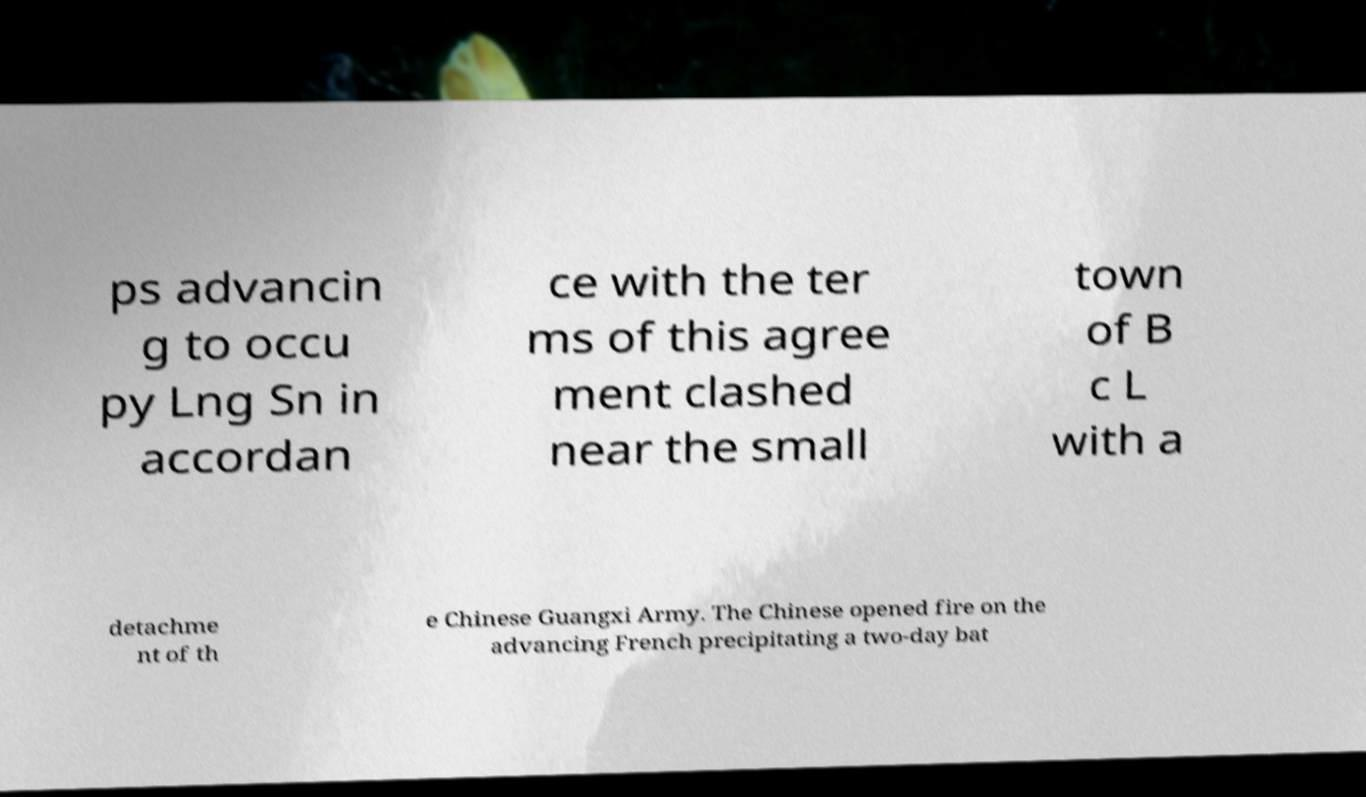Can you read and provide the text displayed in the image?This photo seems to have some interesting text. Can you extract and type it out for me? ps advancin g to occu py Lng Sn in accordan ce with the ter ms of this agree ment clashed near the small town of B c L with a detachme nt of th e Chinese Guangxi Army. The Chinese opened fire on the advancing French precipitating a two-day bat 